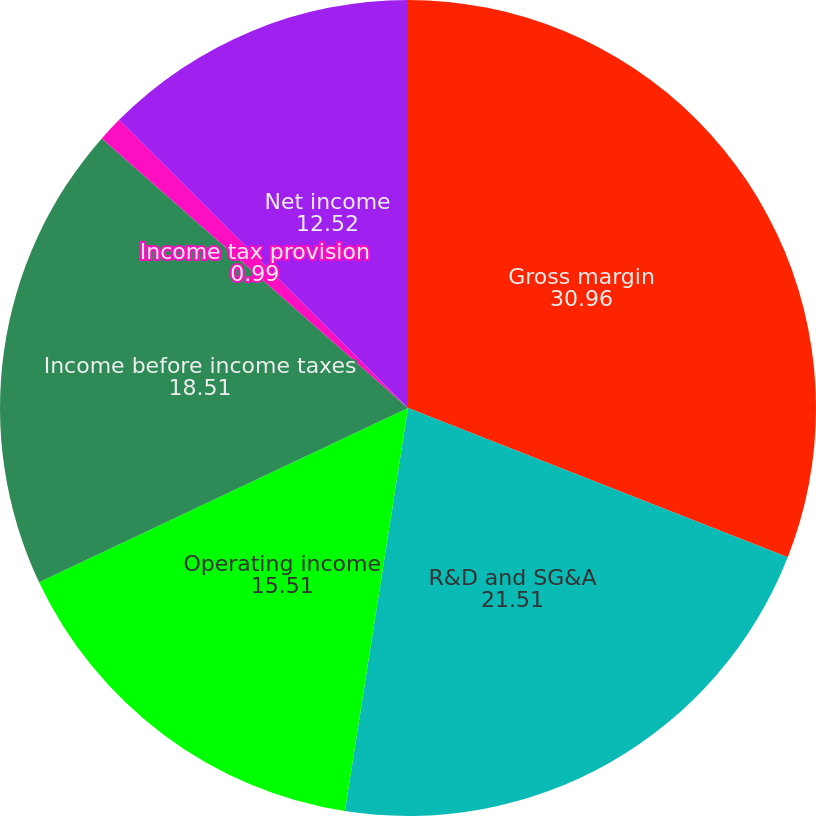Convert chart to OTSL. <chart><loc_0><loc_0><loc_500><loc_500><pie_chart><fcel>Gross margin<fcel>R&D and SG&A<fcel>Operating income<fcel>Income before income taxes<fcel>Income tax provision<fcel>Net income<nl><fcel>30.96%<fcel>21.51%<fcel>15.51%<fcel>18.51%<fcel>0.99%<fcel>12.52%<nl></chart> 